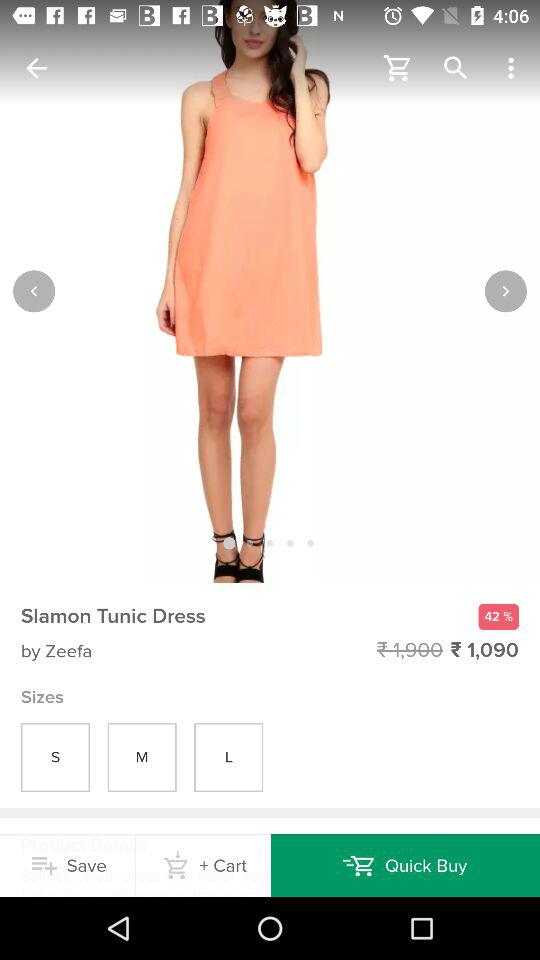Who is the designer of this dress?
When the provided information is insufficient, respond with <no answer>. <no answer> 